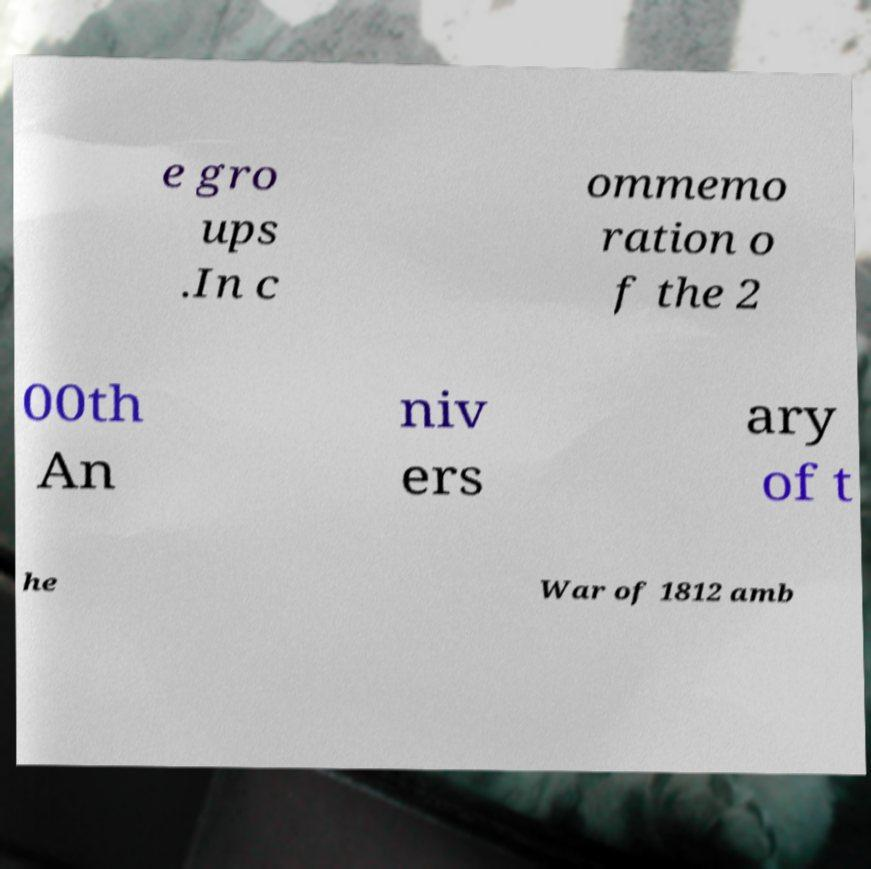Please read and relay the text visible in this image. What does it say? e gro ups .In c ommemo ration o f the 2 00th An niv ers ary of t he War of 1812 amb 